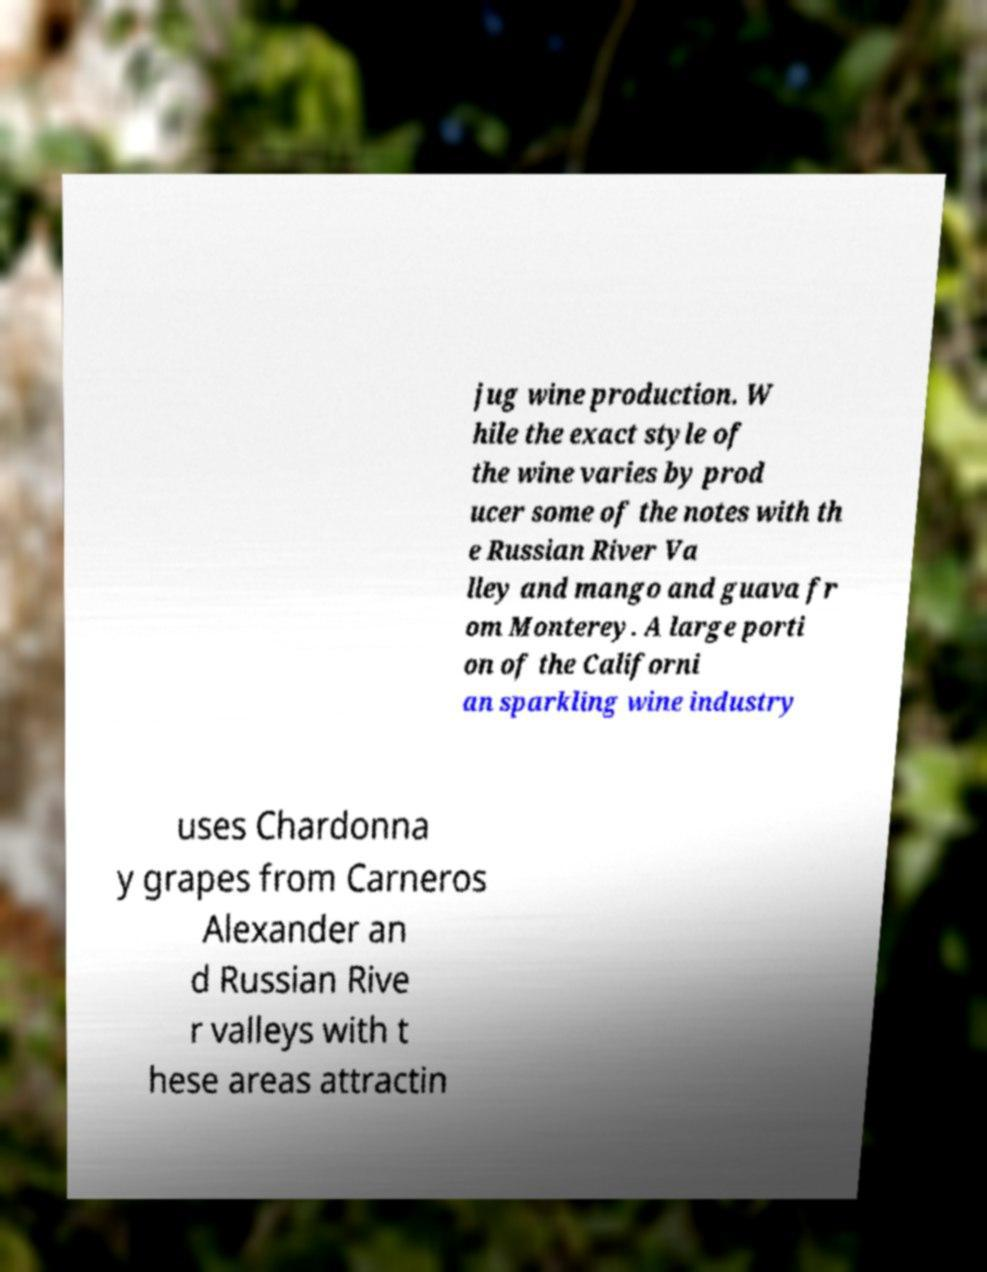For documentation purposes, I need the text within this image transcribed. Could you provide that? jug wine production. W hile the exact style of the wine varies by prod ucer some of the notes with th e Russian River Va lley and mango and guava fr om Monterey. A large porti on of the Californi an sparkling wine industry uses Chardonna y grapes from Carneros Alexander an d Russian Rive r valleys with t hese areas attractin 